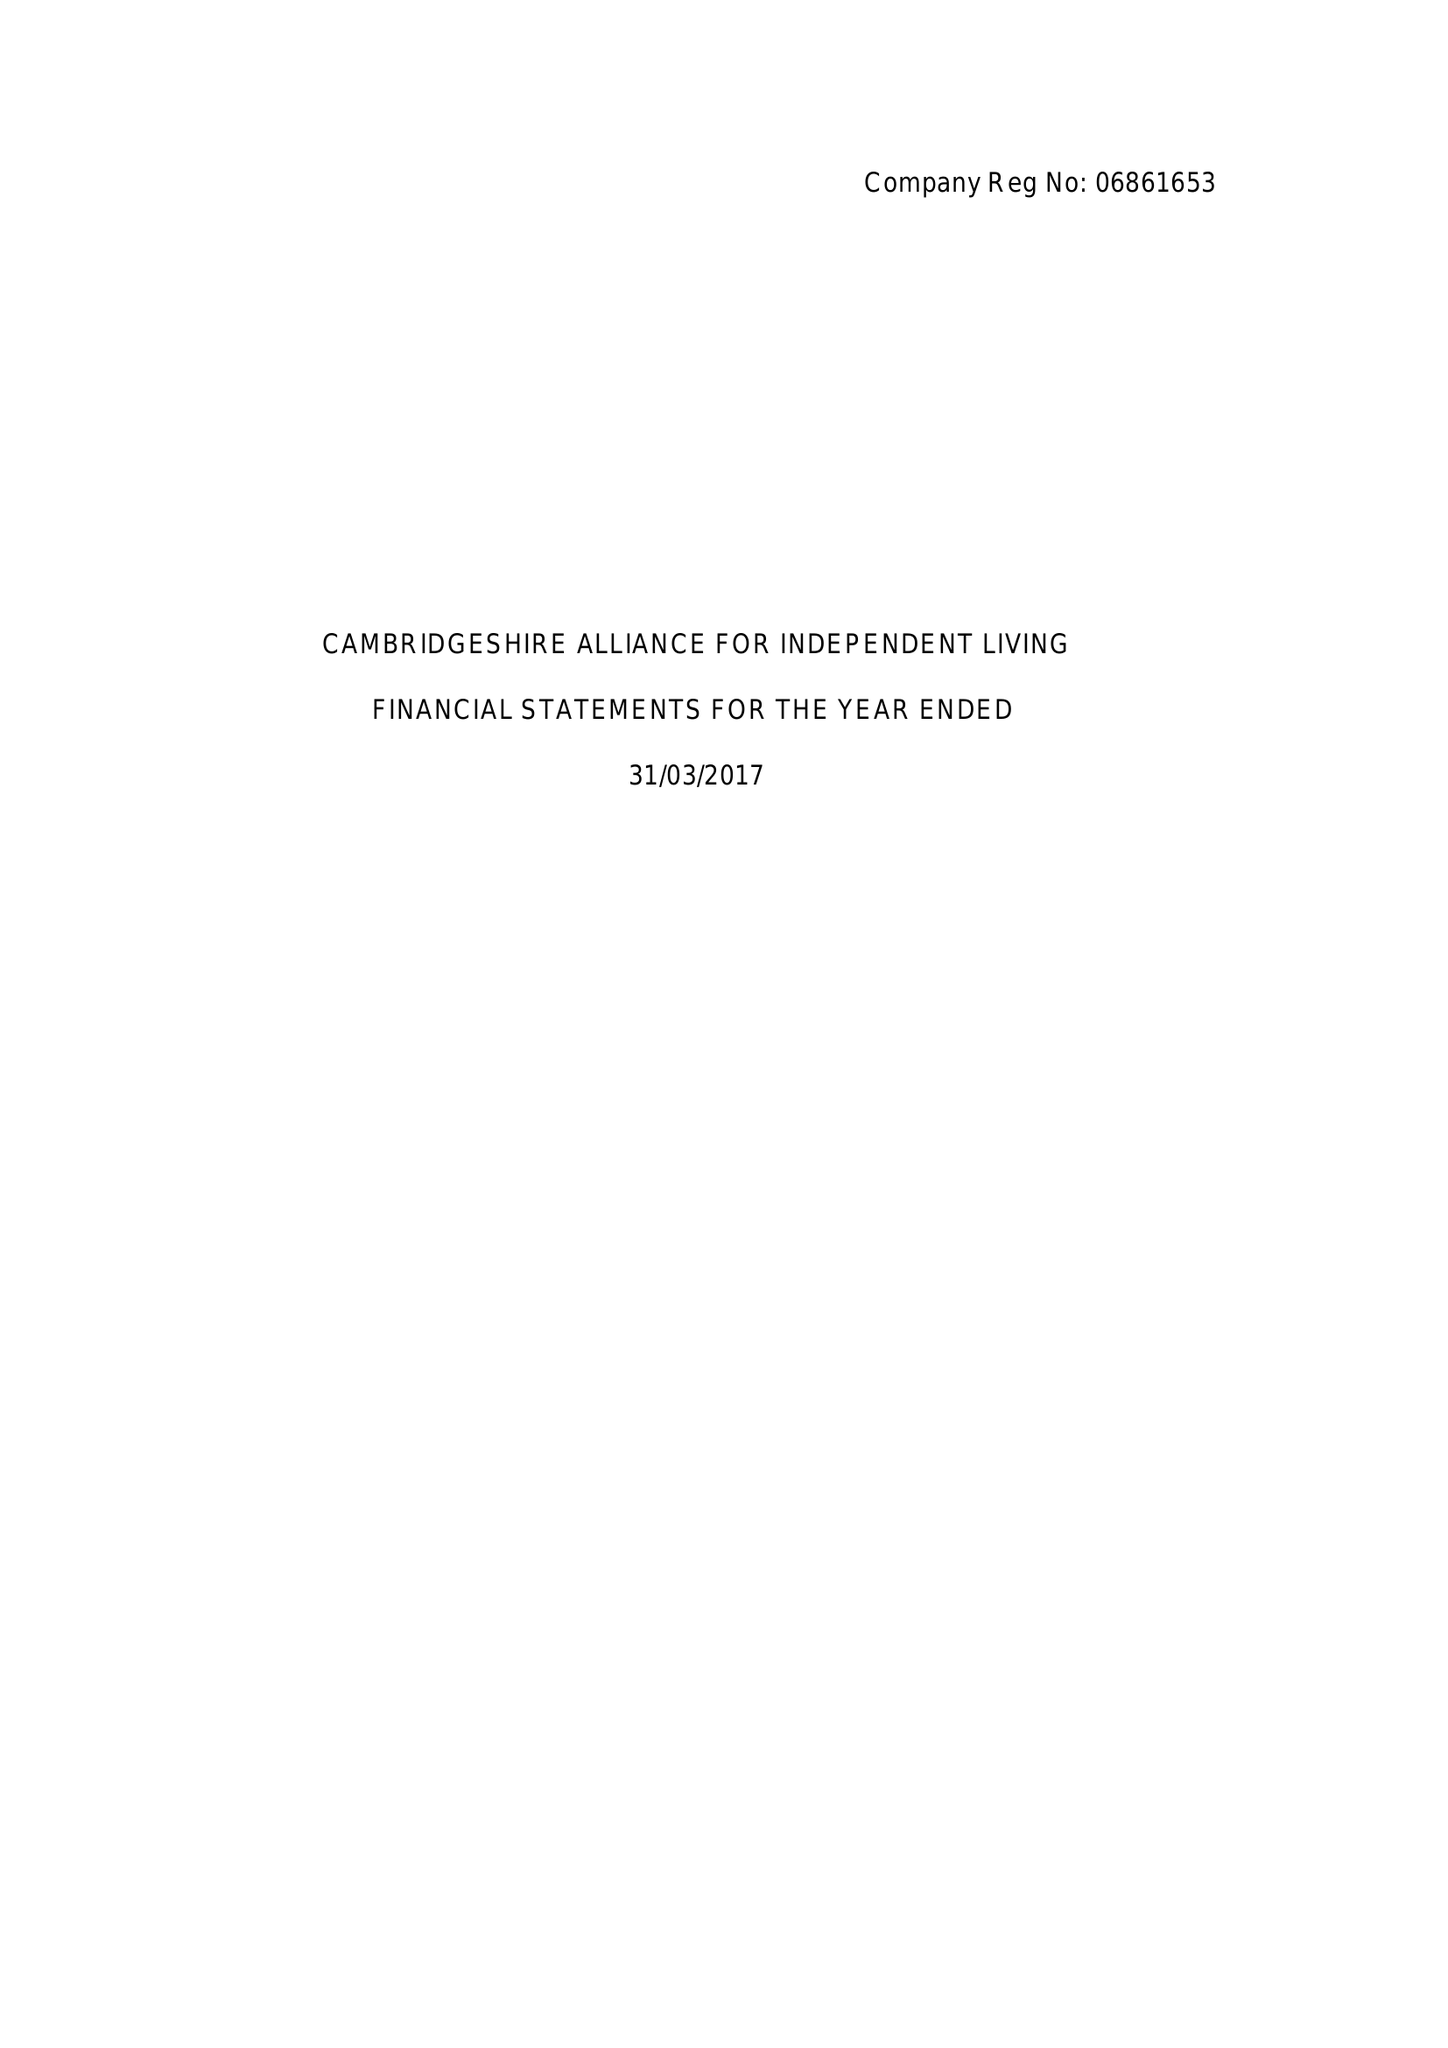What is the value for the report_date?
Answer the question using a single word or phrase. 2017-03-31 